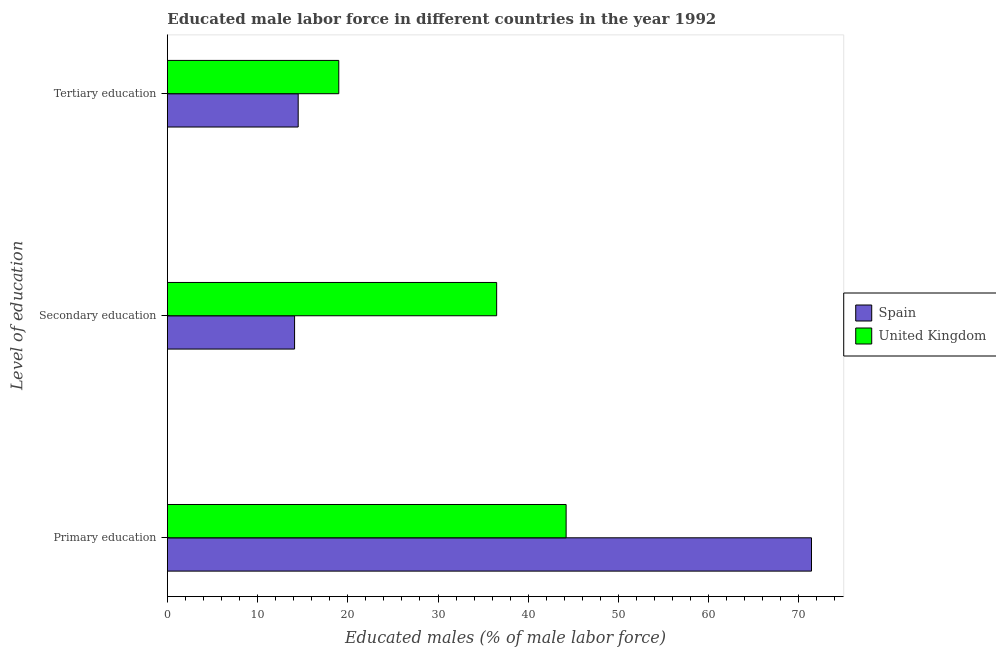How many groups of bars are there?
Your answer should be very brief. 3. Are the number of bars per tick equal to the number of legend labels?
Offer a very short reply. Yes. Are the number of bars on each tick of the Y-axis equal?
Your response must be concise. Yes. How many bars are there on the 3rd tick from the bottom?
Offer a terse response. 2. What is the percentage of male labor force who received primary education in United Kingdom?
Keep it short and to the point. 44.2. Across all countries, what is the maximum percentage of male labor force who received primary education?
Offer a terse response. 71.4. What is the total percentage of male labor force who received primary education in the graph?
Your answer should be compact. 115.6. What is the difference between the percentage of male labor force who received primary education in United Kingdom and that in Spain?
Your answer should be compact. -27.2. What is the difference between the percentage of male labor force who received primary education in Spain and the percentage of male labor force who received tertiary education in United Kingdom?
Your response must be concise. 52.4. What is the average percentage of male labor force who received tertiary education per country?
Your answer should be compact. 16.75. What is the difference between the percentage of male labor force who received secondary education and percentage of male labor force who received primary education in Spain?
Offer a very short reply. -57.3. What is the ratio of the percentage of male labor force who received secondary education in Spain to that in United Kingdom?
Offer a terse response. 0.39. Is the percentage of male labor force who received tertiary education in United Kingdom less than that in Spain?
Keep it short and to the point. No. Is the difference between the percentage of male labor force who received tertiary education in Spain and United Kingdom greater than the difference between the percentage of male labor force who received secondary education in Spain and United Kingdom?
Offer a terse response. Yes. What is the difference between the highest and the second highest percentage of male labor force who received secondary education?
Give a very brief answer. 22.4. In how many countries, is the percentage of male labor force who received tertiary education greater than the average percentage of male labor force who received tertiary education taken over all countries?
Your response must be concise. 1. Is the sum of the percentage of male labor force who received primary education in Spain and United Kingdom greater than the maximum percentage of male labor force who received secondary education across all countries?
Provide a short and direct response. Yes. How many bars are there?
Give a very brief answer. 6. How many countries are there in the graph?
Offer a terse response. 2. Are the values on the major ticks of X-axis written in scientific E-notation?
Ensure brevity in your answer.  No. Does the graph contain any zero values?
Offer a terse response. No. Does the graph contain grids?
Provide a short and direct response. No. Where does the legend appear in the graph?
Make the answer very short. Center right. How are the legend labels stacked?
Your answer should be compact. Vertical. What is the title of the graph?
Make the answer very short. Educated male labor force in different countries in the year 1992. What is the label or title of the X-axis?
Make the answer very short. Educated males (% of male labor force). What is the label or title of the Y-axis?
Provide a short and direct response. Level of education. What is the Educated males (% of male labor force) of Spain in Primary education?
Provide a succinct answer. 71.4. What is the Educated males (% of male labor force) of United Kingdom in Primary education?
Make the answer very short. 44.2. What is the Educated males (% of male labor force) in Spain in Secondary education?
Your answer should be compact. 14.1. What is the Educated males (% of male labor force) in United Kingdom in Secondary education?
Keep it short and to the point. 36.5. What is the Educated males (% of male labor force) in United Kingdom in Tertiary education?
Offer a terse response. 19. Across all Level of education, what is the maximum Educated males (% of male labor force) in Spain?
Your answer should be compact. 71.4. Across all Level of education, what is the maximum Educated males (% of male labor force) of United Kingdom?
Your answer should be very brief. 44.2. Across all Level of education, what is the minimum Educated males (% of male labor force) in Spain?
Provide a succinct answer. 14.1. What is the total Educated males (% of male labor force) in Spain in the graph?
Offer a terse response. 100. What is the total Educated males (% of male labor force) of United Kingdom in the graph?
Ensure brevity in your answer.  99.7. What is the difference between the Educated males (% of male labor force) of Spain in Primary education and that in Secondary education?
Your answer should be very brief. 57.3. What is the difference between the Educated males (% of male labor force) of Spain in Primary education and that in Tertiary education?
Your answer should be very brief. 56.9. What is the difference between the Educated males (% of male labor force) of United Kingdom in Primary education and that in Tertiary education?
Provide a short and direct response. 25.2. What is the difference between the Educated males (% of male labor force) in Spain in Primary education and the Educated males (% of male labor force) in United Kingdom in Secondary education?
Provide a succinct answer. 34.9. What is the difference between the Educated males (% of male labor force) in Spain in Primary education and the Educated males (% of male labor force) in United Kingdom in Tertiary education?
Ensure brevity in your answer.  52.4. What is the difference between the Educated males (% of male labor force) in Spain in Secondary education and the Educated males (% of male labor force) in United Kingdom in Tertiary education?
Your response must be concise. -4.9. What is the average Educated males (% of male labor force) in Spain per Level of education?
Offer a terse response. 33.33. What is the average Educated males (% of male labor force) in United Kingdom per Level of education?
Offer a terse response. 33.23. What is the difference between the Educated males (% of male labor force) of Spain and Educated males (% of male labor force) of United Kingdom in Primary education?
Ensure brevity in your answer.  27.2. What is the difference between the Educated males (% of male labor force) of Spain and Educated males (% of male labor force) of United Kingdom in Secondary education?
Your answer should be compact. -22.4. What is the ratio of the Educated males (% of male labor force) of Spain in Primary education to that in Secondary education?
Keep it short and to the point. 5.06. What is the ratio of the Educated males (% of male labor force) in United Kingdom in Primary education to that in Secondary education?
Your answer should be very brief. 1.21. What is the ratio of the Educated males (% of male labor force) in Spain in Primary education to that in Tertiary education?
Offer a terse response. 4.92. What is the ratio of the Educated males (% of male labor force) of United Kingdom in Primary education to that in Tertiary education?
Provide a succinct answer. 2.33. What is the ratio of the Educated males (% of male labor force) in Spain in Secondary education to that in Tertiary education?
Your answer should be very brief. 0.97. What is the ratio of the Educated males (% of male labor force) in United Kingdom in Secondary education to that in Tertiary education?
Keep it short and to the point. 1.92. What is the difference between the highest and the second highest Educated males (% of male labor force) in Spain?
Your answer should be very brief. 56.9. What is the difference between the highest and the lowest Educated males (% of male labor force) in Spain?
Provide a short and direct response. 57.3. What is the difference between the highest and the lowest Educated males (% of male labor force) in United Kingdom?
Your answer should be compact. 25.2. 